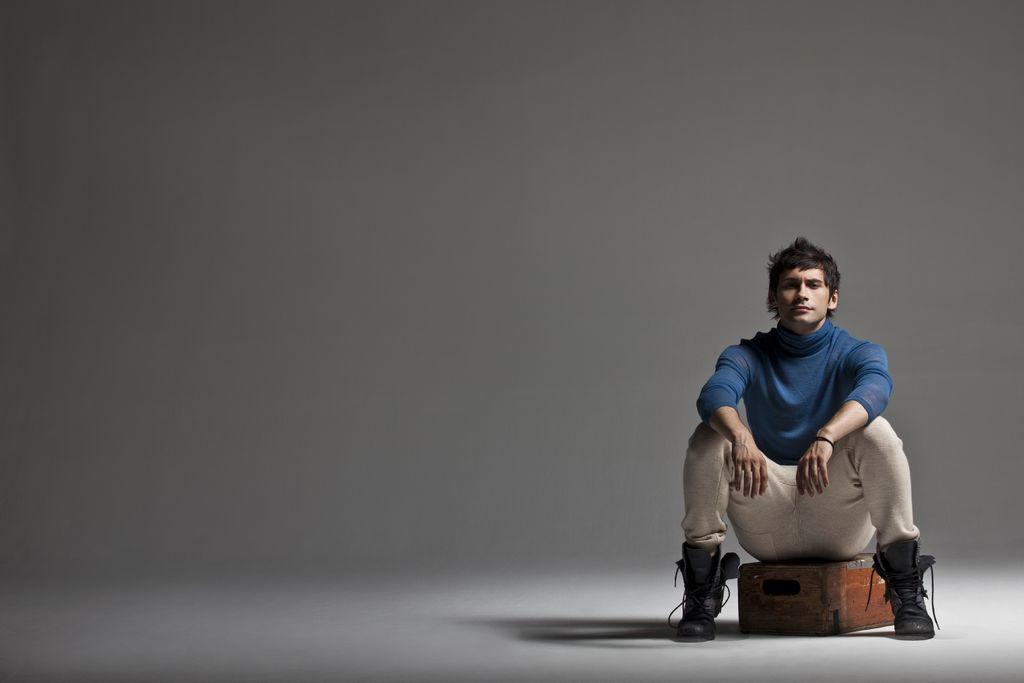Who is the main subject in the image? There is a boy in the image. What is the boy doing in the image? The boy is sitting on a wooden box. Where is the wooden box located in the image? The wooden box is on the right side of the image. What color are the boy's eyes in the image? The provided facts do not mention the color of the boy's eyes, so we cannot determine that information from the image. 